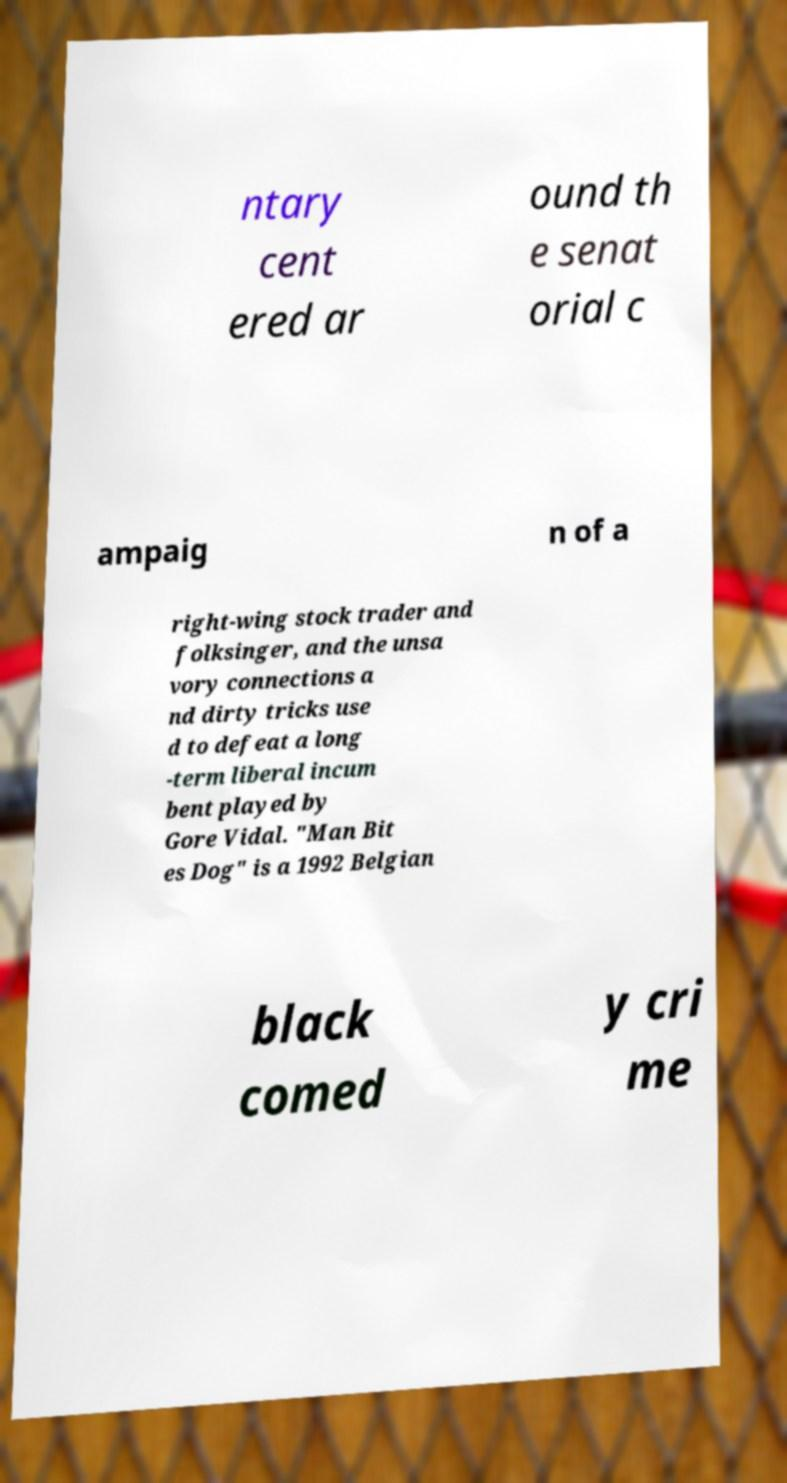Could you extract and type out the text from this image? ntary cent ered ar ound th e senat orial c ampaig n of a right-wing stock trader and folksinger, and the unsa vory connections a nd dirty tricks use d to defeat a long -term liberal incum bent played by Gore Vidal. "Man Bit es Dog" is a 1992 Belgian black comed y cri me 